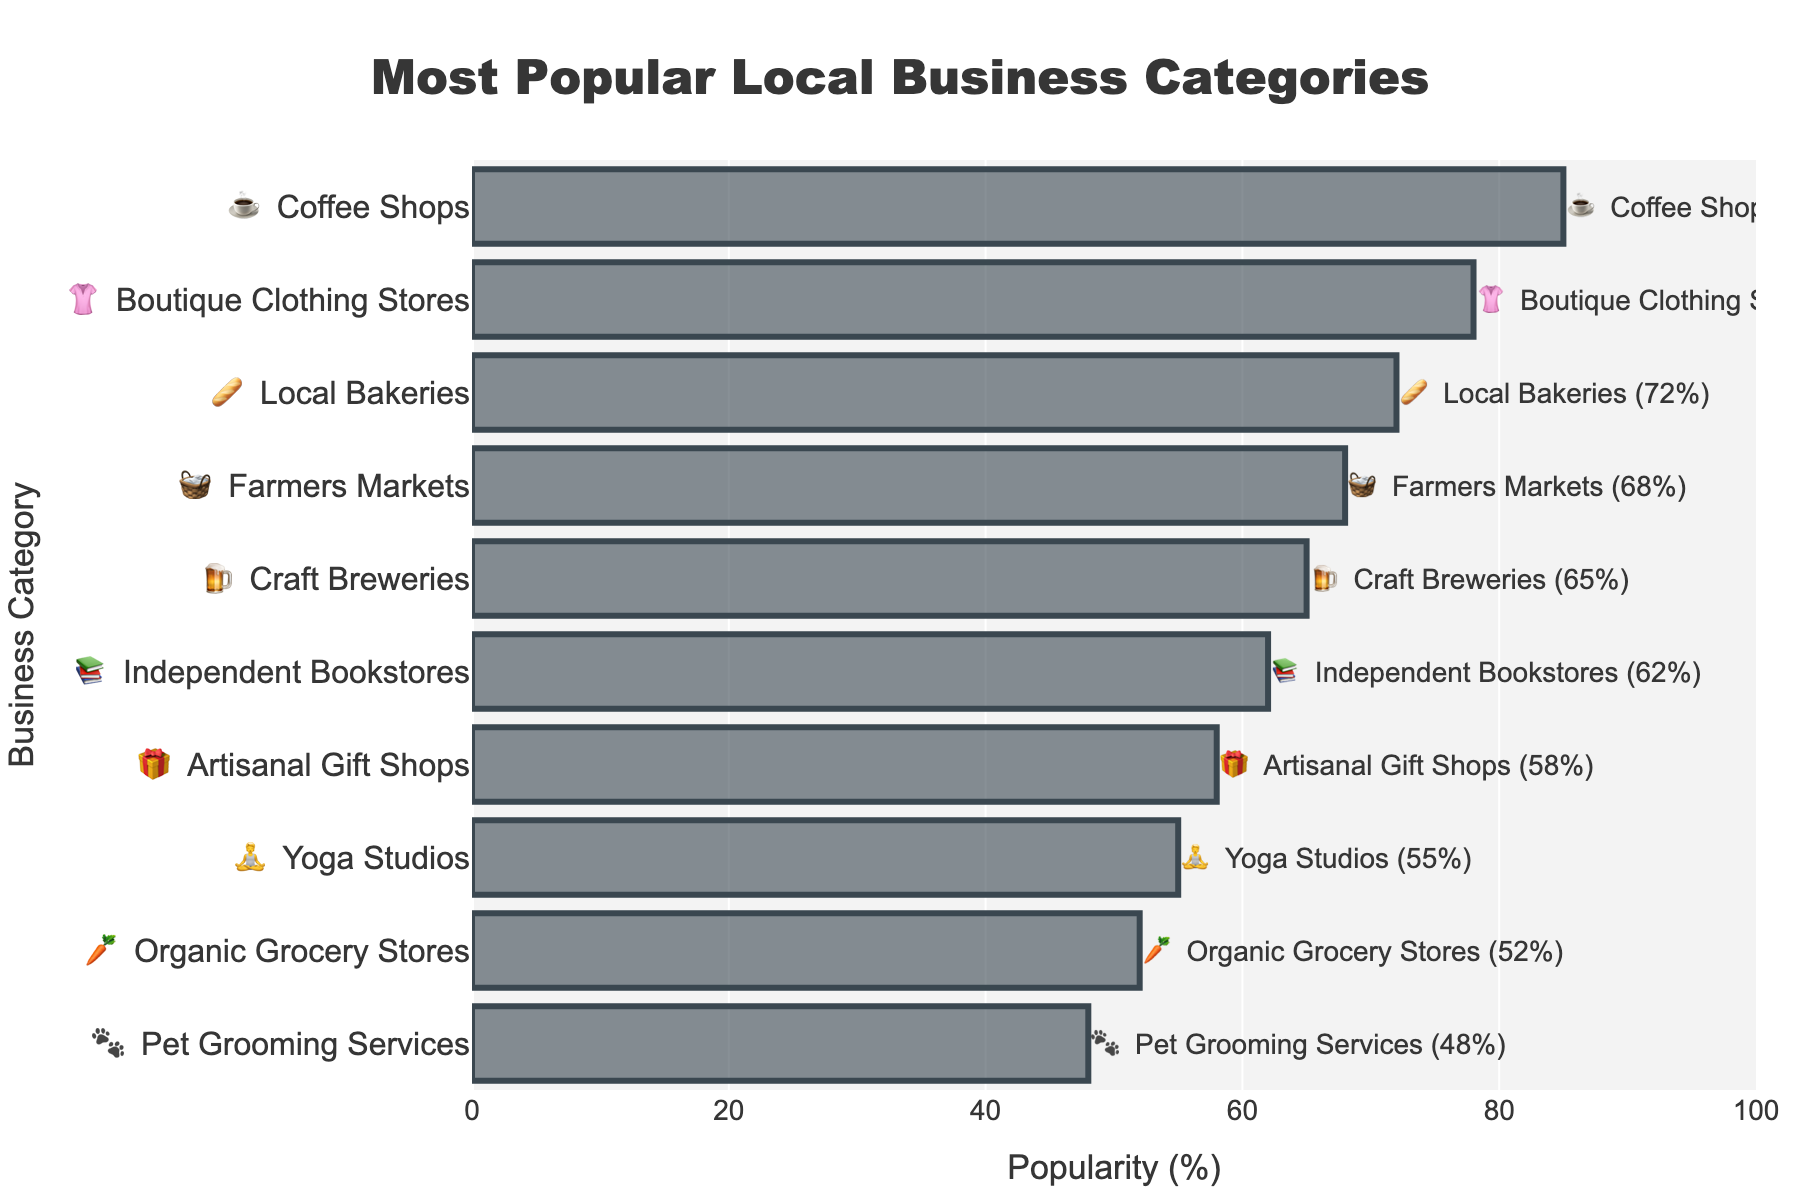what is the title of the chart? The title is prominently displayed at the top of the chart and reads "Most Popular Local Business Categories".
Answer: Most Popular Local Business Categories which local business category has the highest popularity? The category with the highest x-value on the chart, which represents the popularity percentage, is "Coffee Shops" with an emoji ☕.
Answer: Coffee Shops how many local business categories have a popularity of over 60%? Categories with popularity over 60% are visible and easy to count: "Coffee Shops", "Boutique Clothing Stores", "Local Bakeries", "Farmers Markets", "Craft Breweries", and "Independent Bookstores".
Answer: 6 what is the popularity of Pet Grooming Services? The popularity percentage is clearly labeled near the Pet Grooming Services bar, which shows 48%.
Answer: 48% name three categories with the lowest popularity. The categories with the lowest values at the bottom of the chart are "Pet Grooming Services" (🐾), "Organic Grocery Stores" (🥕), and "Yoga Studios" (🧘).
Answer: Pet Grooming Services, Organic Grocery Stores, Yoga Studios what is the difference in popularity between Coffee Shops and Craft Breweries? Coffee Shops have a popularity of 85%, while Craft Breweries have 65%. Subtracting gives: 85 - 65 = 20%.
Answer: 20% which category is more popular: Yoga Studios or Artisanal Gift Shops? Yoga Studios have a popularity of 55%, and Artisanal Gift Shops have 58%. Comparing these numbers shows that Artisanal Gift Shops are more popular.
Answer: Artisanal Gift Shops how is the data about each category displayed next to the bars? The data combines emoji, category name, and popularity percentage shown outside each horizontal bar. For example, it reads as "☕ Coffee Shops (85%)".
Answer: Through emoji, category name, and percentage what is the total popularity percentage of Boutique Clothing Stores and Local Bakeries? Boutique Clothing Stores have a popularity of 78%, and Local Bakeries have 72%. Adding these percentages gives: 78 + 72 = 150%.
Answer: 150% which categories are less popular than Independent Bookstores? Categories below 62% (the popularity of Independent Bookstores) on the chart are "Artisanal Gift Shops", "Yoga Studios", "Organic Grocery Stores", and "Pet Grooming Services".
Answer: Artisanal Gift Shops, Yoga Studios, Organic Grocery Stores, Pet Grooming Services 